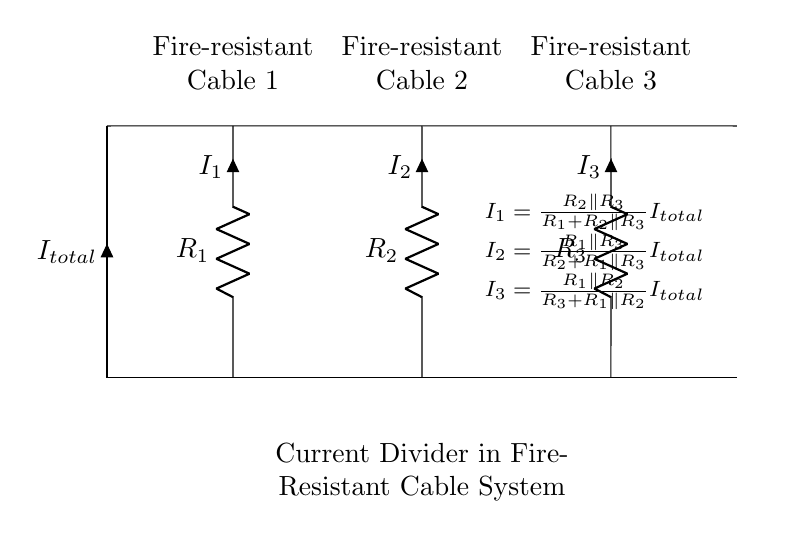What is the total current entering the circuit? The total current, labeled as I_total in the circuit diagram, is the current that is split between the three fire-resistant cables represented by resistors R1, R2, and R3.
Answer: I_total How many resistors are in the circuit? There are three resistors in the circuit diagram, which represent the three fire-resistant cables: R1, R2, and R3.
Answer: 3 What is the function of R1 in the circuit? R1 serves as one of the resistors in the current divider and represents one of the fire-resistant cables. It impacts the distribution of the total current through the circuit.
Answer: Current divider Which resistor has the highest resistance if I1 is the smallest current? If I1 is the smallest current, then R1 must have the highest resistance because a higher resistance leads to a lower current flow in a current divider configuration.
Answer: R1 How do you calculate I1? I1 is calculated using the formula: I1 = (R2 parallel R3) / (R1 + R2 parallel R3) * I_total. This ratio takes into account the resistances of the other two resistors in parallel with R1.
Answer: Formula given in diagram What is I2 if R1 equals R3? If R1 equals R3, the formula for I2 simplifies, since R1 and R3 will impact the current distribution equally, leading to specific values for I2 based on the resistances of R1 and R2. The exact calculation would depend on the numerical values of R1 and R2.
Answer: Calculated based on given R values What is the main purpose of a current divider in a fire-resistant cable system? The main purpose of a current divider in a fire-resistant cable system is to ensure that each cable carries a portion of the current during an emergency, maintaining circuit integrity and avoiding overload.
Answer: Load distribution 